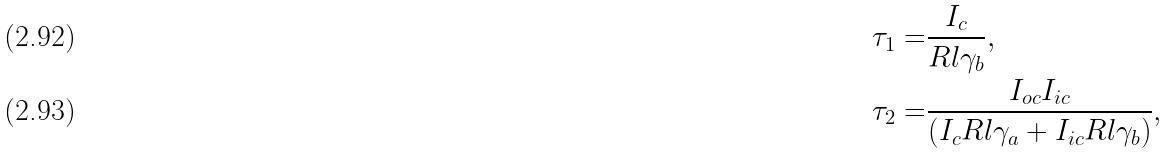<formula> <loc_0><loc_0><loc_500><loc_500>\tau _ { 1 } = & \frac { I _ { c } } { R l \gamma _ { b } } , \\ \tau _ { 2 } = & \frac { I _ { o c } I _ { i c } } { \left ( I _ { c } R l \gamma _ { a } + I _ { i c } R l \gamma _ { b } \right ) } ,</formula> 